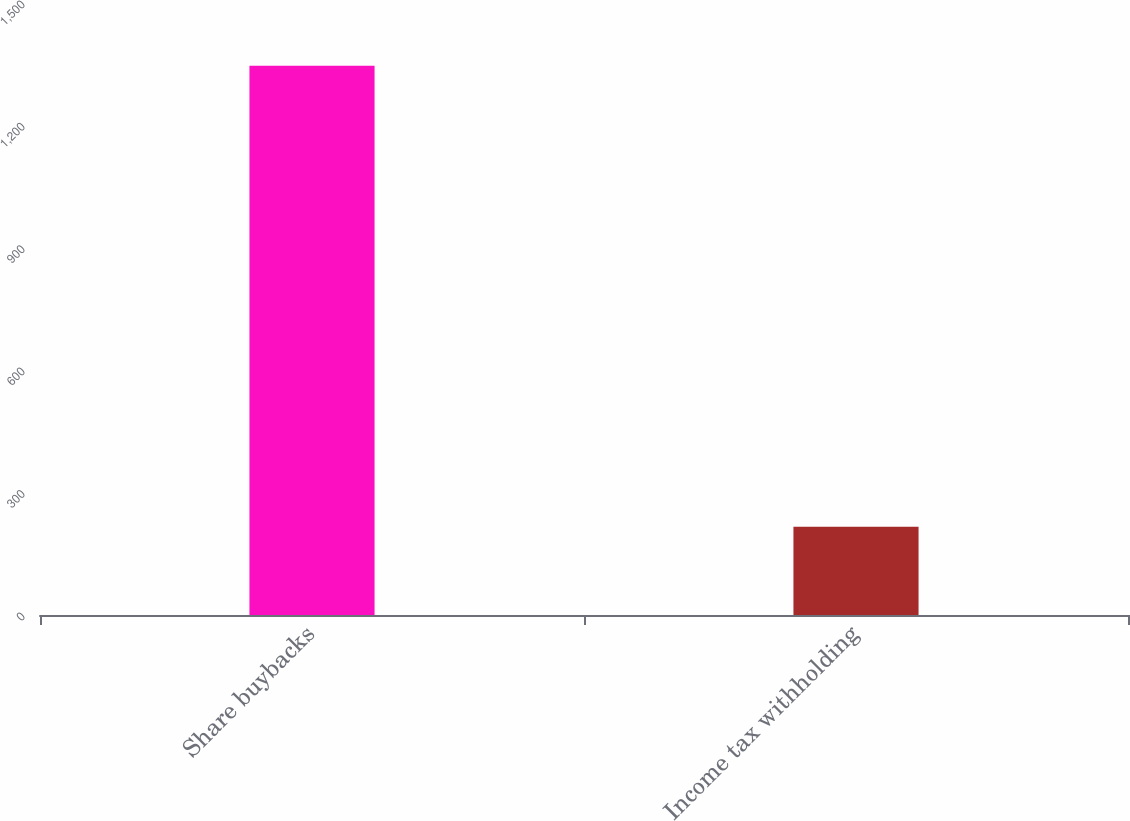Convert chart. <chart><loc_0><loc_0><loc_500><loc_500><bar_chart><fcel>Share buybacks<fcel>Income tax withholding<nl><fcel>1346<fcel>216<nl></chart> 